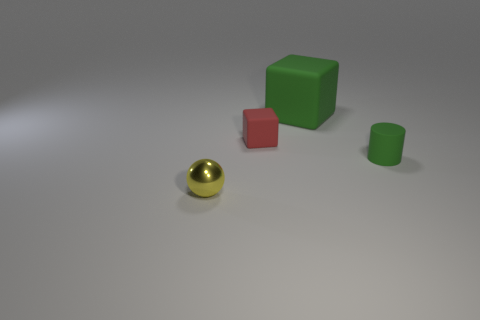Is the color of the large object the same as the tiny cylinder?
Offer a terse response. Yes. How many large blocks have the same color as the tiny cylinder?
Provide a succinct answer. 1. Is the number of big cyan matte balls greater than the number of green blocks?
Your answer should be very brief. No. There is a thing that is behind the ball and to the left of the large green rubber thing; what size is it?
Your answer should be very brief. Small. Does the green object that is to the left of the small cylinder have the same material as the thing that is right of the green rubber block?
Offer a terse response. Yes. The red thing that is the same size as the yellow thing is what shape?
Make the answer very short. Cube. Are there fewer yellow metal balls than green rubber objects?
Offer a terse response. Yes. Is there a rubber object that is on the left side of the tiny object that is on the right side of the green matte block?
Offer a terse response. Yes. Are there any small yellow metallic balls on the right side of the small yellow metallic ball in front of the matte object behind the tiny block?
Ensure brevity in your answer.  No. Do the tiny matte object to the left of the big rubber thing and the green thing that is on the left side of the green rubber cylinder have the same shape?
Provide a succinct answer. Yes. 